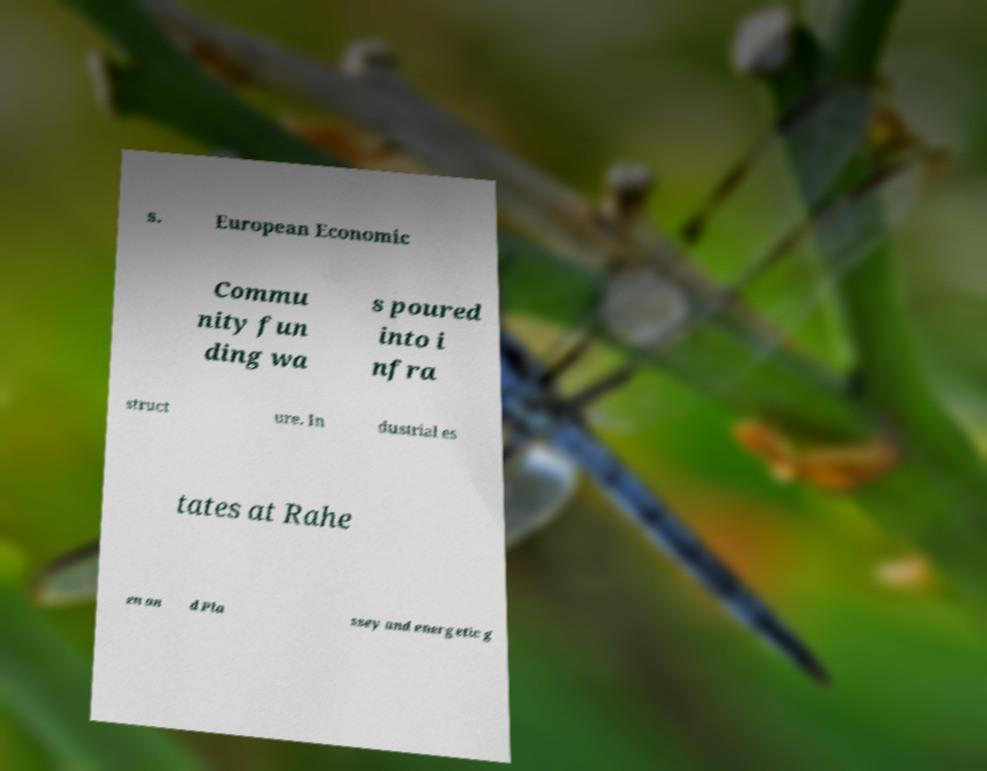For documentation purposes, I need the text within this image transcribed. Could you provide that? s. European Economic Commu nity fun ding wa s poured into i nfra struct ure. In dustrial es tates at Rahe en an d Pla ssey and energetic g 